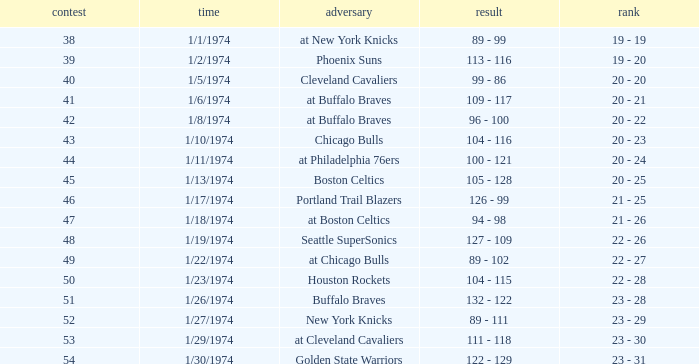What was the record after game 51 on 1/27/1974? 23 - 29. 